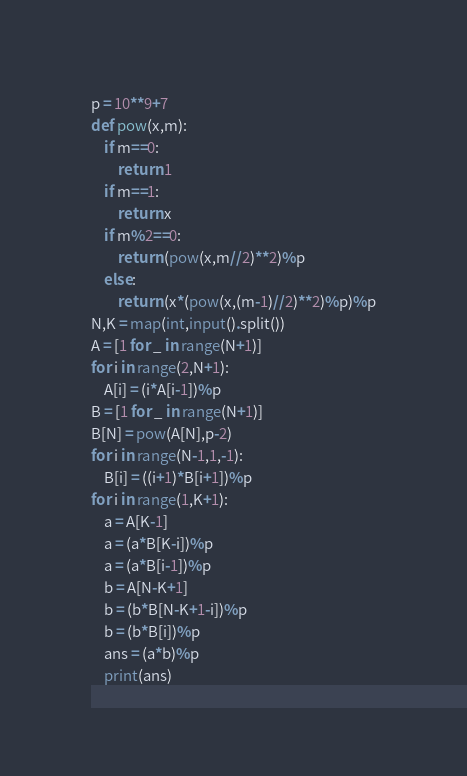<code> <loc_0><loc_0><loc_500><loc_500><_Python_>p = 10**9+7
def pow(x,m):
    if m==0:
        return 1
    if m==1:
        return x
    if m%2==0:
        return (pow(x,m//2)**2)%p
    else:
        return (x*(pow(x,(m-1)//2)**2)%p)%p
N,K = map(int,input().split())
A = [1 for _ in range(N+1)]
for i in range(2,N+1):
    A[i] = (i*A[i-1])%p
B = [1 for _ in range(N+1)]
B[N] = pow(A[N],p-2)
for i in range(N-1,1,-1):
    B[i] = ((i+1)*B[i+1])%p
for i in range(1,K+1):
    a = A[K-1]
    a = (a*B[K-i])%p
    a = (a*B[i-1])%p
    b = A[N-K+1]
    b = (b*B[N-K+1-i])%p
    b = (b*B[i])%p
    ans = (a*b)%p
    print(ans)</code> 